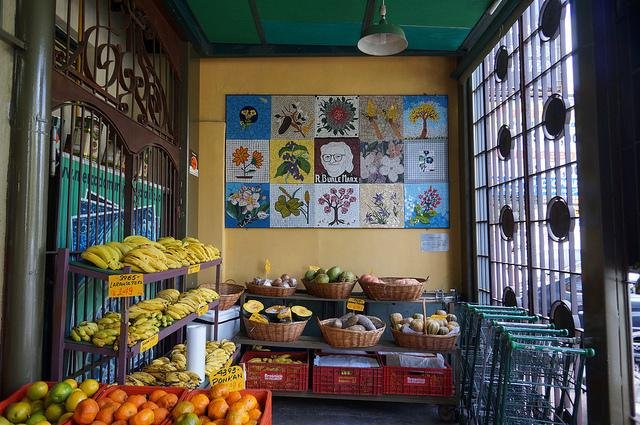Why are the fruits in the basket?

Choices:
A) to clean
B) to sell
C) to decorate
D) to eat to sell 